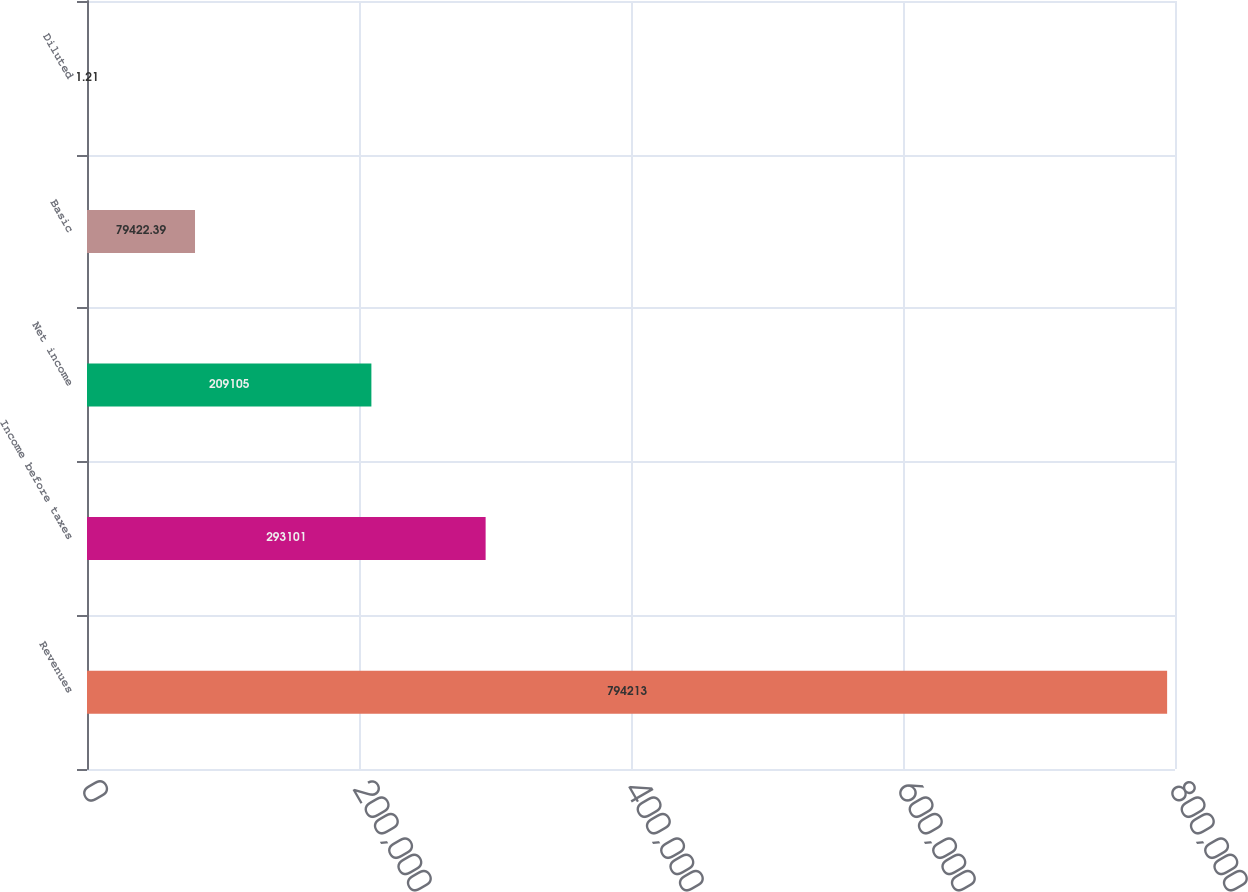Convert chart. <chart><loc_0><loc_0><loc_500><loc_500><bar_chart><fcel>Revenues<fcel>Income before taxes<fcel>Net income<fcel>Basic<fcel>Diluted<nl><fcel>794213<fcel>293101<fcel>209105<fcel>79422.4<fcel>1.21<nl></chart> 